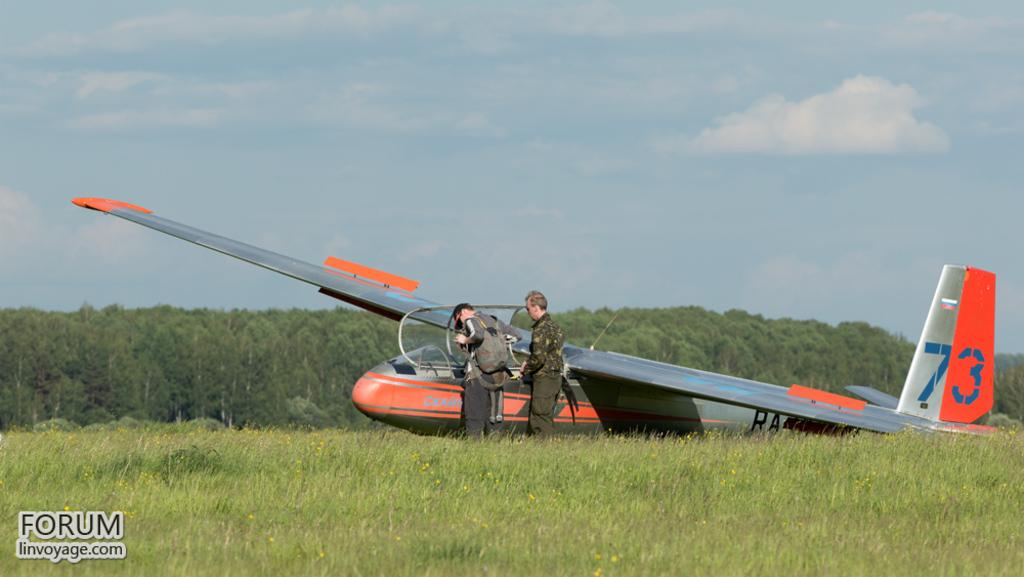<image>
Provide a brief description of the given image. A picture of a plane with the number 73 from FORUM linvoyage.com. 